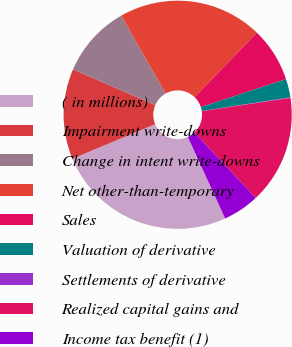Convert chart. <chart><loc_0><loc_0><loc_500><loc_500><pie_chart><fcel>( in millions)<fcel>Impairment write-downs<fcel>Change in intent write-downs<fcel>Net other-than-temporary<fcel>Sales<fcel>Valuation of derivative<fcel>Settlements of derivative<fcel>Realized capital gains and<fcel>Income tax benefit (1)<nl><fcel>25.54%<fcel>12.81%<fcel>10.26%<fcel>20.45%<fcel>7.72%<fcel>2.62%<fcel>0.08%<fcel>15.36%<fcel>5.17%<nl></chart> 